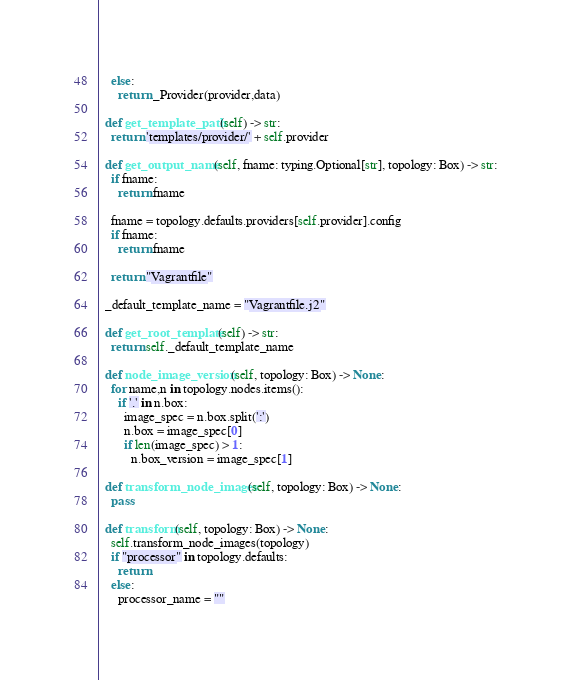<code> <loc_0><loc_0><loc_500><loc_500><_Python_>    else:
      return _Provider(provider,data)

  def get_template_path(self) -> str:
    return 'templates/provider/' + self.provider

  def get_output_name(self, fname: typing.Optional[str], topology: Box) -> str:
    if fname:
      return fname

    fname = topology.defaults.providers[self.provider].config
    if fname:
      return fname

    return "Vagrantfile"

  _default_template_name = "Vagrantfile.j2"

  def get_root_template(self) -> str:
    return self._default_template_name

  def node_image_version(self, topology: Box) -> None:
    for name,n in topology.nodes.items():
      if '.' in n.box:
        image_spec = n.box.split(':')
        n.box = image_spec[0]
        if len(image_spec) > 1:
          n.box_version = image_spec[1]

  def transform_node_images(self, topology: Box) -> None:
    pass

  def transform(self, topology: Box) -> None:
    self.transform_node_images(topology)
    if "processor" in topology.defaults:
      return
    else:
      processor_name = ""</code> 